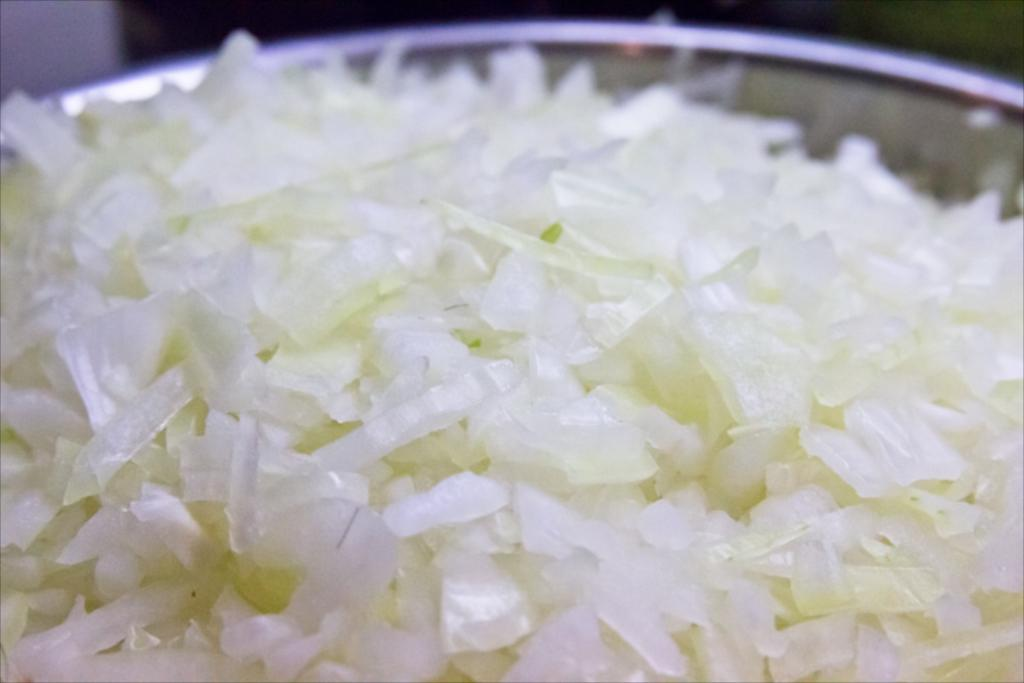What type of food item is visible in the image? There are chopped onion pieces in the image. Where are the chopped onion pieces located? The chopped onion pieces are in a plate. How many chairs are visible in the image? There are no chairs present in the image; it only features chopped onion pieces in a plate. 